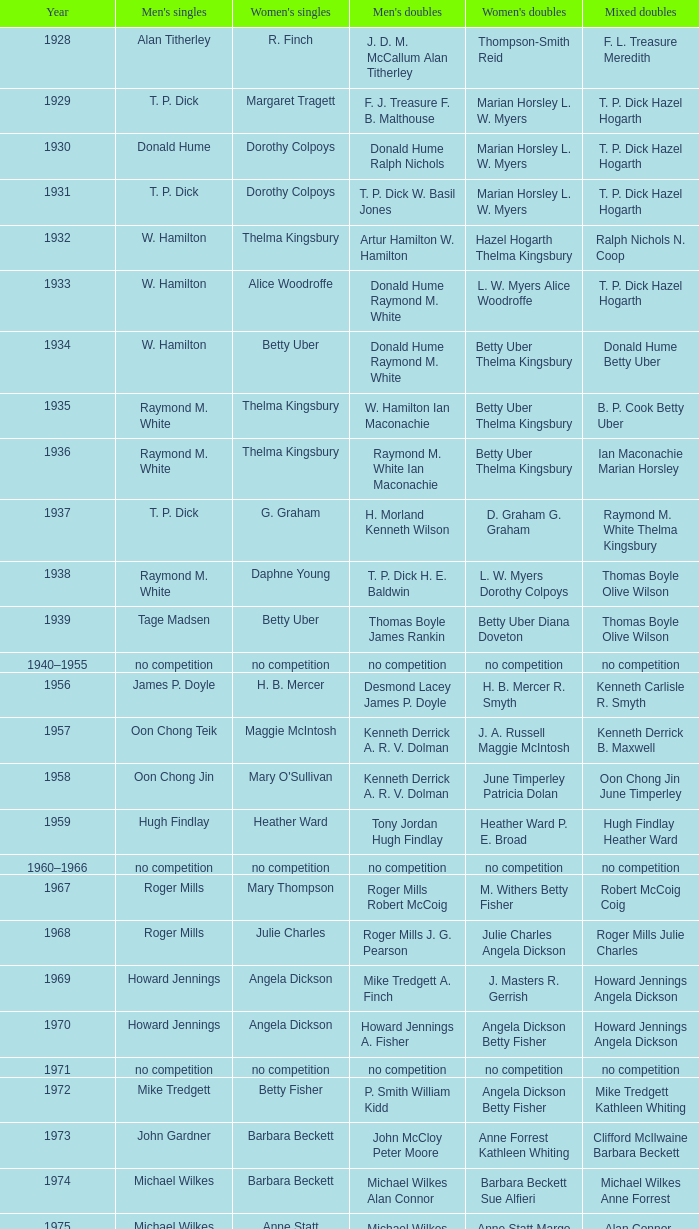Parse the table in full. {'header': ['Year', "Men's singles", "Women's singles", "Men's doubles", "Women's doubles", 'Mixed doubles'], 'rows': [['1928', 'Alan Titherley', 'R. Finch', 'J. D. M. McCallum Alan Titherley', 'Thompson-Smith Reid', 'F. L. Treasure Meredith'], ['1929', 'T. P. Dick', 'Margaret Tragett', 'F. J. Treasure F. B. Malthouse', 'Marian Horsley L. W. Myers', 'T. P. Dick Hazel Hogarth'], ['1930', 'Donald Hume', 'Dorothy Colpoys', 'Donald Hume Ralph Nichols', 'Marian Horsley L. W. Myers', 'T. P. Dick Hazel Hogarth'], ['1931', 'T. P. Dick', 'Dorothy Colpoys', 'T. P. Dick W. Basil Jones', 'Marian Horsley L. W. Myers', 'T. P. Dick Hazel Hogarth'], ['1932', 'W. Hamilton', 'Thelma Kingsbury', 'Artur Hamilton W. Hamilton', 'Hazel Hogarth Thelma Kingsbury', 'Ralph Nichols N. Coop'], ['1933', 'W. Hamilton', 'Alice Woodroffe', 'Donald Hume Raymond M. White', 'L. W. Myers Alice Woodroffe', 'T. P. Dick Hazel Hogarth'], ['1934', 'W. Hamilton', 'Betty Uber', 'Donald Hume Raymond M. White', 'Betty Uber Thelma Kingsbury', 'Donald Hume Betty Uber'], ['1935', 'Raymond M. White', 'Thelma Kingsbury', 'W. Hamilton Ian Maconachie', 'Betty Uber Thelma Kingsbury', 'B. P. Cook Betty Uber'], ['1936', 'Raymond M. White', 'Thelma Kingsbury', 'Raymond M. White Ian Maconachie', 'Betty Uber Thelma Kingsbury', 'Ian Maconachie Marian Horsley'], ['1937', 'T. P. Dick', 'G. Graham', 'H. Morland Kenneth Wilson', 'D. Graham G. Graham', 'Raymond M. White Thelma Kingsbury'], ['1938', 'Raymond M. White', 'Daphne Young', 'T. P. Dick H. E. Baldwin', 'L. W. Myers Dorothy Colpoys', 'Thomas Boyle Olive Wilson'], ['1939', 'Tage Madsen', 'Betty Uber', 'Thomas Boyle James Rankin', 'Betty Uber Diana Doveton', 'Thomas Boyle Olive Wilson'], ['1940–1955', 'no competition', 'no competition', 'no competition', 'no competition', 'no competition'], ['1956', 'James P. Doyle', 'H. B. Mercer', 'Desmond Lacey James P. Doyle', 'H. B. Mercer R. Smyth', 'Kenneth Carlisle R. Smyth'], ['1957', 'Oon Chong Teik', 'Maggie McIntosh', 'Kenneth Derrick A. R. V. Dolman', 'J. A. Russell Maggie McIntosh', 'Kenneth Derrick B. Maxwell'], ['1958', 'Oon Chong Jin', "Mary O'Sullivan", 'Kenneth Derrick A. R. V. Dolman', 'June Timperley Patricia Dolan', 'Oon Chong Jin June Timperley'], ['1959', 'Hugh Findlay', 'Heather Ward', 'Tony Jordan Hugh Findlay', 'Heather Ward P. E. Broad', 'Hugh Findlay Heather Ward'], ['1960–1966', 'no competition', 'no competition', 'no competition', 'no competition', 'no competition'], ['1967', 'Roger Mills', 'Mary Thompson', 'Roger Mills Robert McCoig', 'M. Withers Betty Fisher', 'Robert McCoig Coig'], ['1968', 'Roger Mills', 'Julie Charles', 'Roger Mills J. G. Pearson', 'Julie Charles Angela Dickson', 'Roger Mills Julie Charles'], ['1969', 'Howard Jennings', 'Angela Dickson', 'Mike Tredgett A. Finch', 'J. Masters R. Gerrish', 'Howard Jennings Angela Dickson'], ['1970', 'Howard Jennings', 'Angela Dickson', 'Howard Jennings A. Fisher', 'Angela Dickson Betty Fisher', 'Howard Jennings Angela Dickson'], ['1971', 'no competition', 'no competition', 'no competition', 'no competition', 'no competition'], ['1972', 'Mike Tredgett', 'Betty Fisher', 'P. Smith William Kidd', 'Angela Dickson Betty Fisher', 'Mike Tredgett Kathleen Whiting'], ['1973', 'John Gardner', 'Barbara Beckett', 'John McCloy Peter Moore', 'Anne Forrest Kathleen Whiting', 'Clifford McIlwaine Barbara Beckett'], ['1974', 'Michael Wilkes', 'Barbara Beckett', 'Michael Wilkes Alan Connor', 'Barbara Beckett Sue Alfieri', 'Michael Wilkes Anne Forrest'], ['1975', 'Michael Wilkes', 'Anne Statt', 'Michael Wilkes Alan Connor', 'Anne Statt Margo Winter', 'Alan Connor Margo Winter'], ['1976', 'Kevin Jolly', 'Pat Davies', 'Tim Stokes Kevin Jolly', 'Angela Dickson Sue Brimble', 'Howard Jennings Angela Dickson'], ['1977', 'David Eddy', 'Paula Kilvington', 'David Eddy Eddy Sutton', 'Anne Statt Jane Webster', 'David Eddy Barbara Giles'], ['1978', 'Mike Tredgett', 'Gillian Gilks', 'David Eddy Eddy Sutton', 'Barbara Sutton Marjan Ridder', 'Elliot Stuart Gillian Gilks'], ['1979', 'Kevin Jolly', 'Nora Perry', 'Ray Stevens Mike Tredgett', 'Barbara Sutton Nora Perry', 'Mike Tredgett Nora Perry'], ['1980', 'Thomas Kihlström', 'Jane Webster', 'Thomas Kihlström Bengt Fröman', 'Jane Webster Karen Puttick', 'Billy Gilliland Karen Puttick'], ['1981', 'Ray Stevens', 'Gillian Gilks', 'Ray Stevens Mike Tredgett', 'Gillian Gilks Paula Kilvington', 'Mike Tredgett Nora Perry'], ['1982', 'Steve Baddeley', 'Karen Bridge', 'David Eddy Eddy Sutton', 'Karen Chapman Sally Podger', 'Billy Gilliland Karen Chapman'], ['1983', 'Steve Butler', 'Sally Podger', 'Mike Tredgett Dipak Tailor', 'Nora Perry Jane Webster', 'Dipak Tailor Nora Perry'], ['1984', 'Steve Butler', 'Karen Beckman', 'Mike Tredgett Martin Dew', 'Helen Troke Karen Chapman', 'Mike Tredgett Karen Chapman'], ['1985', 'Morten Frost', 'Charlotte Hattens', 'Billy Gilliland Dan Travers', 'Gillian Gilks Helen Troke', 'Martin Dew Gillian Gilks'], ['1986', 'Darren Hall', 'Fiona Elliott', 'Martin Dew Dipak Tailor', 'Karen Beckman Sara Halsall', 'Jesper Knudsen Nettie Nielsen'], ['1987', 'Darren Hall', 'Fiona Elliott', 'Martin Dew Darren Hall', 'Karen Beckman Sara Halsall', 'Martin Dew Gillian Gilks'], ['1988', 'Vimal Kumar', 'Lee Jung-mi', 'Richard Outterside Mike Brown', 'Fiona Elliott Sara Halsall', 'Martin Dew Gillian Gilks'], ['1989', 'Darren Hall', 'Bang Soo-hyun', 'Nick Ponting Dave Wright', 'Karen Beckman Sara Sankey', 'Mike Brown Jillian Wallwork'], ['1990', 'Mathew Smith', 'Joanne Muggeridge', 'Nick Ponting Dave Wright', 'Karen Chapman Sara Sankey', 'Dave Wright Claire Palmer'], ['1991', 'Vimal Kumar', 'Denyse Julien', 'Nick Ponting Dave Wright', 'Cheryl Johnson Julie Bradbury', 'Nick Ponting Joanne Wright'], ['1992', 'Wei Yan', 'Fiona Smith', 'Michael Adams Chris Rees', 'Denyse Julien Doris Piché', 'Andy Goode Joanne Wright'], ['1993', 'Anders Nielsen', 'Sue Louis Lane', 'Nick Ponting Dave Wright', 'Julie Bradbury Sara Sankey', 'Nick Ponting Joanne Wright'], ['1994', 'Darren Hall', 'Marina Andrievskaya', 'Michael Adams Simon Archer', 'Julie Bradbury Joanne Wright', 'Chris Hunt Joanne Wright'], ['1995', 'Peter Rasmussen', 'Denyse Julien', 'Andrei Andropov Nikolai Zuyev', 'Julie Bradbury Joanne Wright', 'Nick Ponting Joanne Wright'], ['1996', 'Colin Haughton', 'Elena Rybkina', 'Andrei Andropov Nikolai Zuyev', 'Elena Rybkina Marina Yakusheva', 'Nikolai Zuyev Marina Yakusheva'], ['1997', 'Chris Bruil', 'Kelly Morgan', 'Ian Pearson James Anderson', 'Nicole van Hooren Brenda Conijn', 'Quinten van Dalm Nicole van Hooren'], ['1998', 'Dicky Palyama', 'Brenda Beenhakker', 'James Anderson Ian Sullivan', 'Sara Sankey Ella Tripp', 'James Anderson Sara Sankey'], ['1999', 'Daniel Eriksson', 'Marina Andrievskaya', 'Joachim Tesche Jean-Philippe Goyette', 'Marina Andrievskaya Catrine Bengtsson', 'Henrik Andersson Marina Andrievskaya'], ['2000', 'Richard Vaughan', 'Marina Yakusheva', 'Joachim Andersson Peter Axelsson', 'Irina Ruslyakova Marina Yakusheva', 'Peter Jeffrey Joanne Davies'], ['2001', 'Irwansyah', 'Brenda Beenhakker', 'Vincent Laigle Svetoslav Stoyanov', 'Sara Sankey Ella Tripp', 'Nikolai Zuyev Marina Yakusheva'], ['2002', 'Irwansyah', 'Karina de Wit', 'Nikolai Zuyev Stanislav Pukhov', 'Ella Tripp Joanne Wright', 'Nikolai Zuyev Marina Yakusheva'], ['2003', 'Irwansyah', 'Ella Karachkova', 'Ashley Thilthorpe Kristian Roebuck', 'Ella Karachkova Anastasia Russkikh', 'Alexandr Russkikh Anastasia Russkikh'], ['2004', 'Nathan Rice', 'Petya Nedelcheva', 'Reuben Gordown Aji Basuki Sindoro', 'Petya Nedelcheva Yuan Wemyss', 'Matthew Hughes Kelly Morgan'], ['2005', 'Chetan Anand', 'Eleanor Cox', 'Andrew Ellis Dean George', 'Hayley Connor Heather Olver', 'Valiyaveetil Diju Jwala Gutta'], ['2006', 'Irwansyah', 'Huang Chia-chi', 'Matthew Hughes Martyn Lewis', 'Natalie Munt Mariana Agathangelou', 'Kristian Roebuck Natalie Munt'], ['2007', 'Marc Zwiebler', 'Jill Pittard', 'Wojciech Szkudlarczyk Adam Cwalina', 'Chloe Magee Bing Huang', 'Wojciech Szkudlarczyk Malgorzata Kurdelska'], ['2008', 'Brice Leverdez', 'Kati Tolmoff', 'Andrew Bowman Martyn Lewis', 'Mariana Agathangelou Jillie Cooper', 'Watson Briggs Jillie Cooper'], ['2009', 'Kristian Nielsen', 'Tatjana Bibik', 'Vitaliy Durkin Alexandr Nikolaenko', 'Valeria Sorokina Nina Vislova', 'Vitaliy Durkin Nina Vislova'], ['2010', 'Pablo Abián', 'Anita Raj Kaur', 'Peter Käsbauer Josche Zurwonne', 'Joanne Quay Swee Ling Anita Raj Kaur', 'Peter Käsbauer Johanna Goliszewski'], ['2011', 'Niluka Karunaratne', 'Nicole Schaller', 'Chris Coles Matthew Nottingham', 'Ng Hui Ern Ng Hui Lin', 'Martin Campbell Ng Hui Lin'], ['2012', 'Chou Tien-chen', 'Chiang Mei-hui', 'Marcus Ellis Paul Van Rietvelde', 'Gabrielle White Lauren Smith', 'Marcus Ellis Gabrielle White']]} In the year jesper knudsen and nettie nielsen were victorious in mixed doubles, who were the women's doubles champions? Karen Beckman Sara Halsall. 